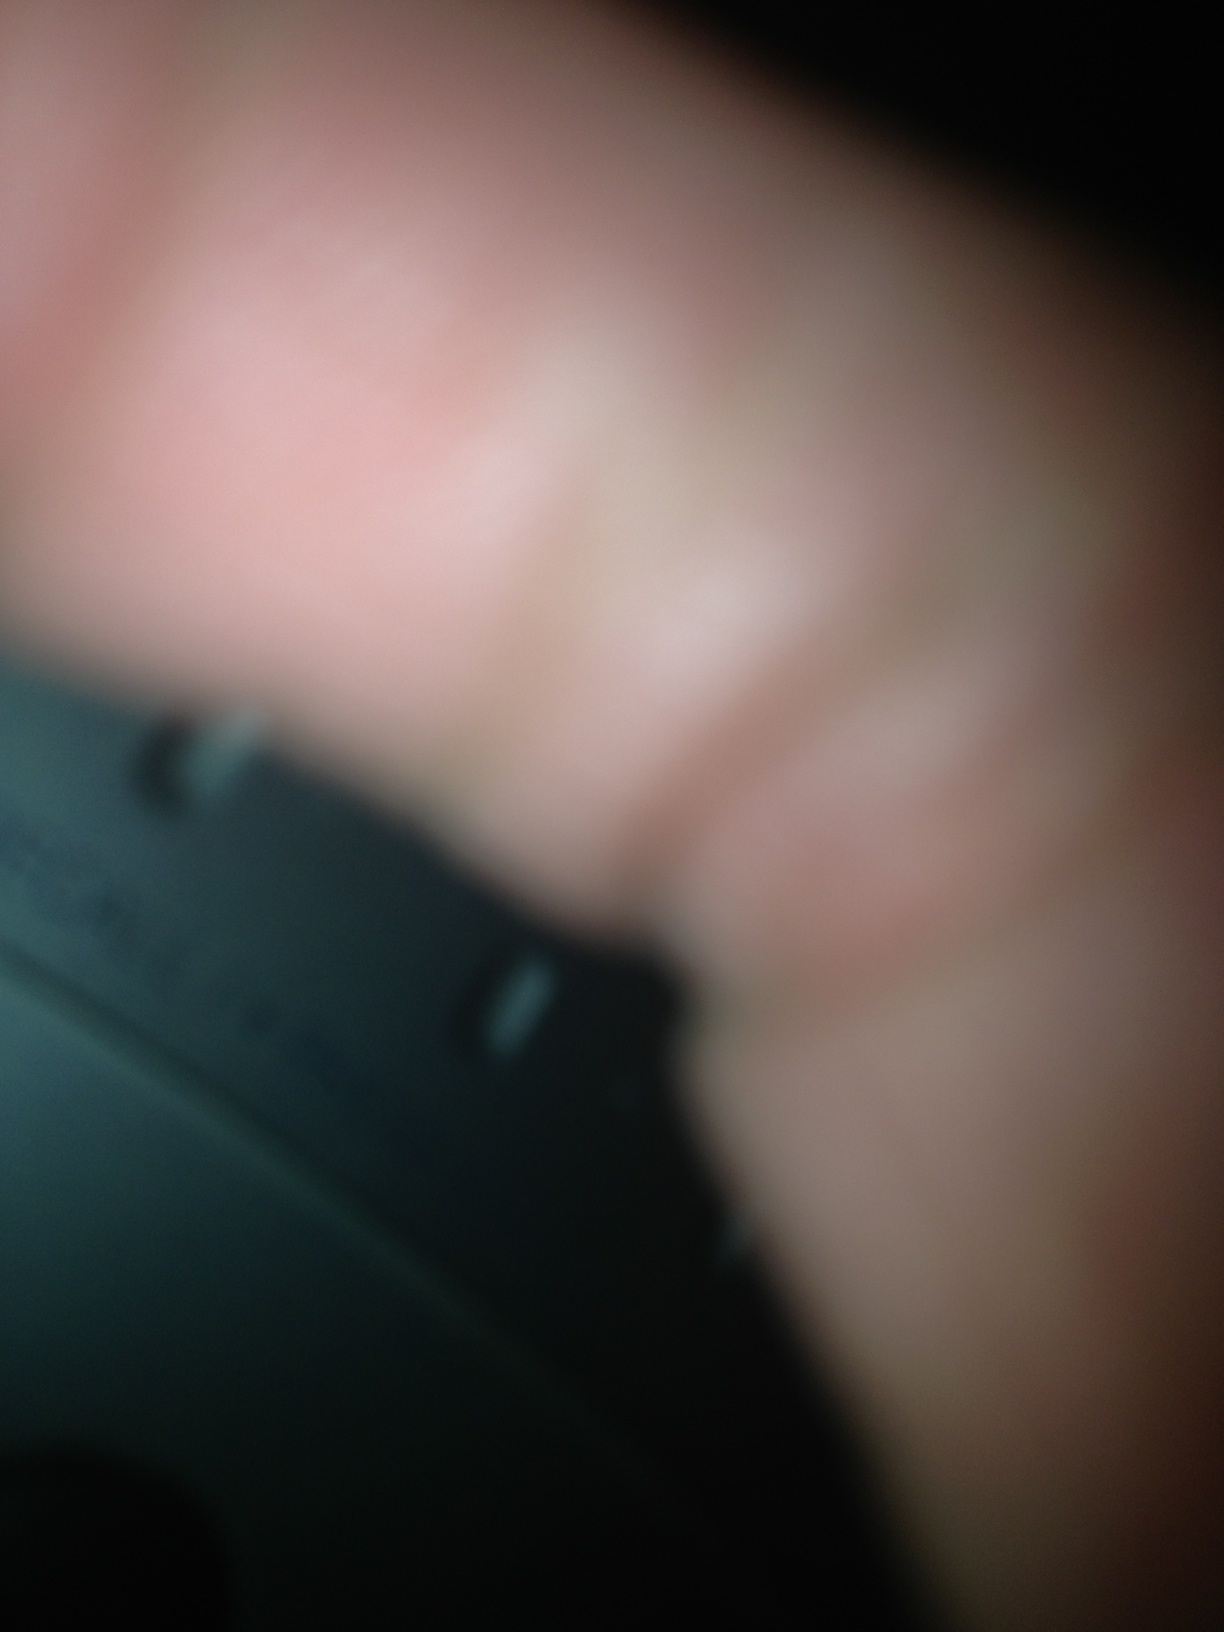Is that a radio? Based on the provided image, it's challenging to determine if the object in question is a radio due to the blurriness and the presence of a finger obscuring much of the view. However, the partial view of a black, round object with what appears to be markings might suggest it could be electronic equipment or a component of a radio. More clarity in the image would be needed for a definitive answer. 